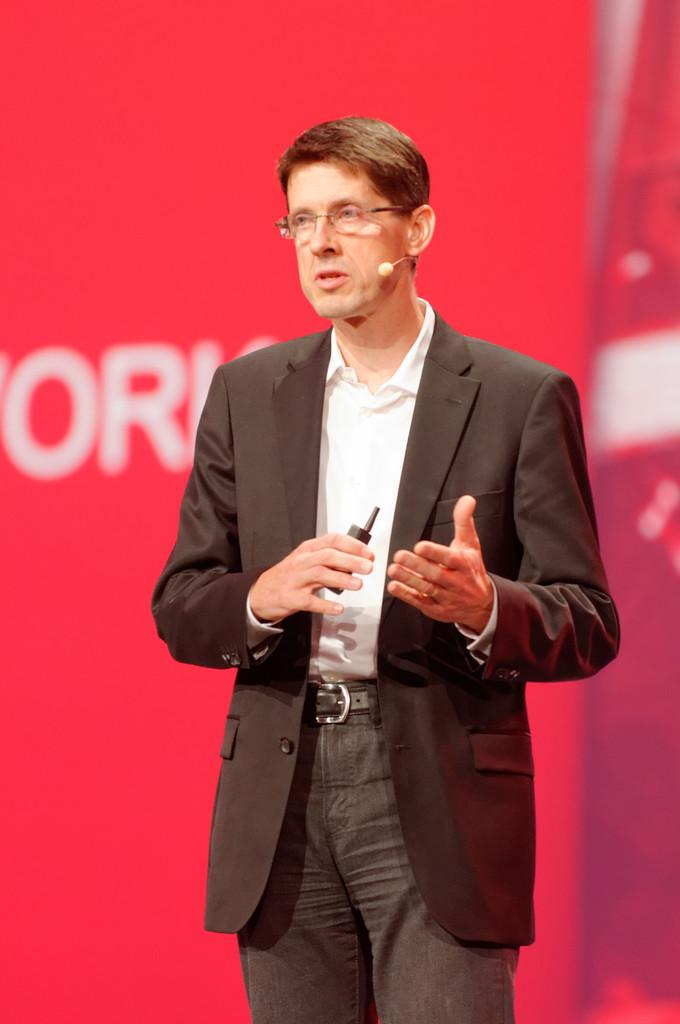Who is present in the image? There is a man in the image. What is the man doing in the image? The man is standing on the floor. What is the man holding in his hand? The man is holding an electronic device in his hand. What can be seen in the background of the image? There is an advertisement in the background of the image. What type of needle is the man using to sew in the image? There is no needle present in the image; the man is holding an electronic device. Can you describe the wave pattern in the image? There is no wave pattern present in the image; it features a man standing on the floor with an electronic device in his hand and an advertisement in the background. 